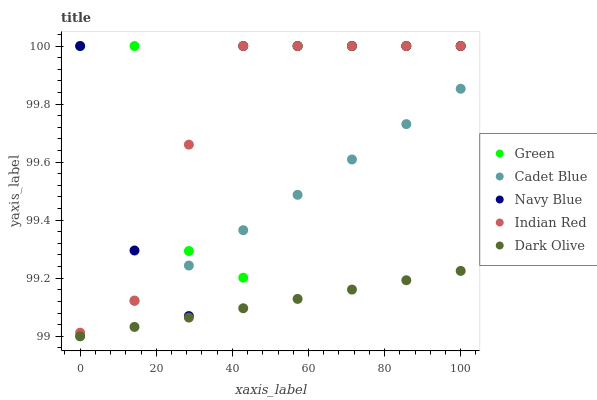Does Dark Olive have the minimum area under the curve?
Answer yes or no. Yes. Does Green have the maximum area under the curve?
Answer yes or no. Yes. Does Navy Blue have the minimum area under the curve?
Answer yes or no. No. Does Navy Blue have the maximum area under the curve?
Answer yes or no. No. Is Dark Olive the smoothest?
Answer yes or no. Yes. Is Green the roughest?
Answer yes or no. Yes. Is Navy Blue the smoothest?
Answer yes or no. No. Is Navy Blue the roughest?
Answer yes or no. No. Does Dark Olive have the lowest value?
Answer yes or no. Yes. Does Navy Blue have the lowest value?
Answer yes or no. No. Does Indian Red have the highest value?
Answer yes or no. Yes. Does Cadet Blue have the highest value?
Answer yes or no. No. Is Dark Olive less than Green?
Answer yes or no. Yes. Is Indian Red greater than Dark Olive?
Answer yes or no. Yes. Does Green intersect Cadet Blue?
Answer yes or no. Yes. Is Green less than Cadet Blue?
Answer yes or no. No. Is Green greater than Cadet Blue?
Answer yes or no. No. Does Dark Olive intersect Green?
Answer yes or no. No. 